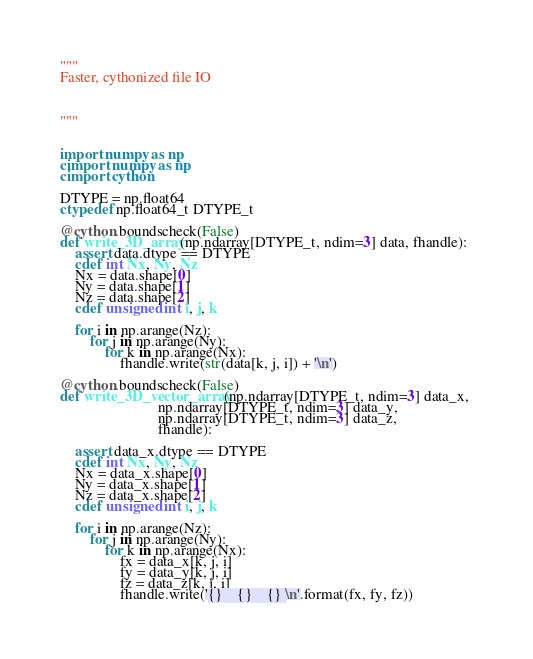Convert code to text. <code><loc_0><loc_0><loc_500><loc_500><_Cython_>"""
Faster, cythonized file IO



"""


import numpy as np
cimport numpy as np
cimport cython

DTYPE = np.float64
ctypedef np.float64_t DTYPE_t

@cython.boundscheck(False)
def write_3D_array(np.ndarray[DTYPE_t, ndim=3] data, fhandle):
    assert data.dtype == DTYPE
    cdef int Nx, Ny, Nz
    Nx = data.shape[0]
    Ny = data.shape[1]
    Nz = data.shape[2]
    cdef unsigned int i, j, k

    for i in np.arange(Nz):
        for j in np.arange(Ny):
            for k in np.arange(Nx):
                fhandle.write(str(data[k, j, i]) + '\n')

@cython.boundscheck(False)
def write_3D_vector_array(np.ndarray[DTYPE_t, ndim=3] data_x, 
                          np.ndarray[DTYPE_t, ndim=3] data_y,
                          np.ndarray[DTYPE_t, ndim=3] data_z,
                          fhandle):

    assert data_x.dtype == DTYPE
    cdef int Nx, Ny, Nz
    Nx = data_x.shape[0]
    Ny = data_x.shape[1]
    Nz = data_x.shape[2]
    cdef unsigned int i, j, k

    for i in np.arange(Nz):
        for j in np.arange(Ny):
            for k in np.arange(Nx):
                fx = data_x[k, j, i]
                fy = data_y[k, j, i]
                fz = data_z[k, j, i]
                fhandle.write('{}    {}    {} \n'.format(fx, fy, fz))
</code> 